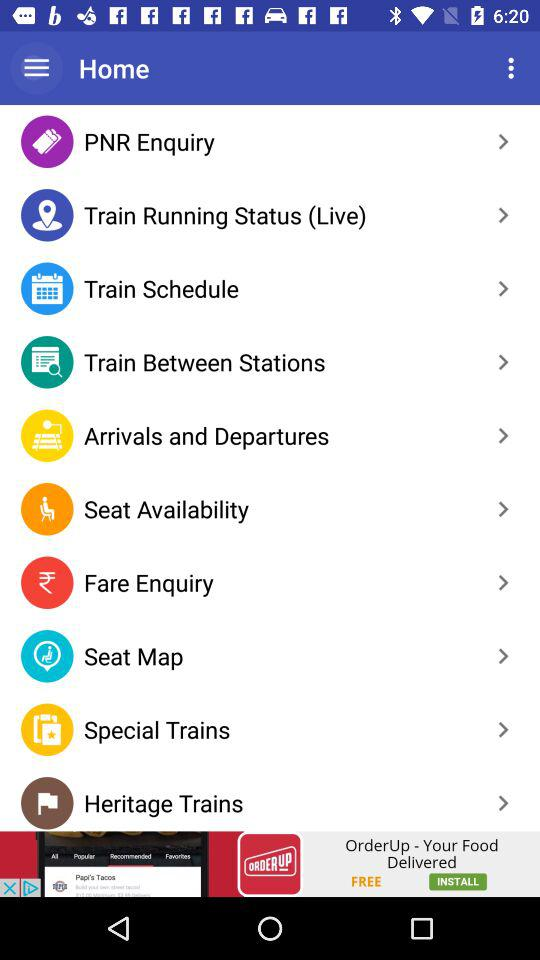Which is the latest version given to update? The latest version given to update is 3.5.2. 